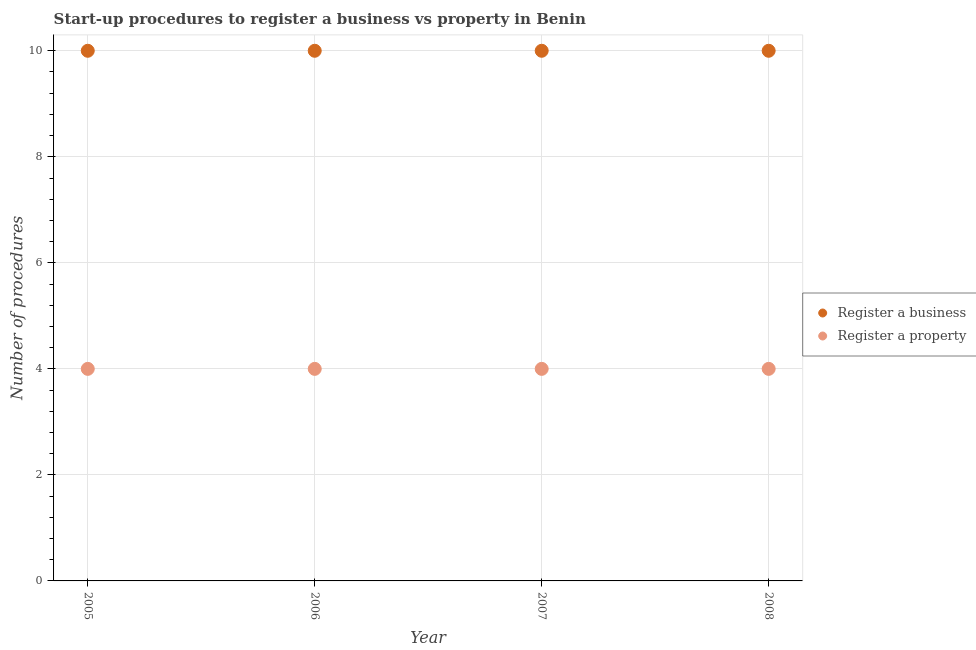Is the number of dotlines equal to the number of legend labels?
Offer a terse response. Yes. What is the number of procedures to register a property in 2005?
Give a very brief answer. 4. Across all years, what is the maximum number of procedures to register a property?
Your response must be concise. 4. Across all years, what is the minimum number of procedures to register a business?
Make the answer very short. 10. In which year was the number of procedures to register a business maximum?
Offer a very short reply. 2005. What is the total number of procedures to register a business in the graph?
Keep it short and to the point. 40. What is the difference between the number of procedures to register a property in 2005 and the number of procedures to register a business in 2008?
Your response must be concise. -6. What is the average number of procedures to register a business per year?
Make the answer very short. 10. In the year 2006, what is the difference between the number of procedures to register a property and number of procedures to register a business?
Make the answer very short. -6. In how many years, is the number of procedures to register a business greater than 2.4?
Ensure brevity in your answer.  4. Is the number of procedures to register a business in 2007 less than that in 2008?
Offer a very short reply. No. Does the number of procedures to register a business monotonically increase over the years?
Offer a terse response. No. Is the number of procedures to register a business strictly greater than the number of procedures to register a property over the years?
Give a very brief answer. Yes. Does the graph contain any zero values?
Provide a succinct answer. No. Does the graph contain grids?
Keep it short and to the point. Yes. How many legend labels are there?
Keep it short and to the point. 2. How are the legend labels stacked?
Provide a short and direct response. Vertical. What is the title of the graph?
Provide a succinct answer. Start-up procedures to register a business vs property in Benin. Does "Resident workers" appear as one of the legend labels in the graph?
Provide a succinct answer. No. What is the label or title of the Y-axis?
Make the answer very short. Number of procedures. What is the Number of procedures in Register a business in 2005?
Give a very brief answer. 10. What is the Number of procedures of Register a property in 2005?
Provide a short and direct response. 4. What is the Number of procedures in Register a property in 2006?
Offer a very short reply. 4. What is the Number of procedures of Register a business in 2007?
Your answer should be compact. 10. What is the Number of procedures in Register a property in 2007?
Offer a very short reply. 4. What is the Number of procedures in Register a property in 2008?
Your answer should be very brief. 4. Across all years, what is the minimum Number of procedures of Register a property?
Make the answer very short. 4. What is the total Number of procedures of Register a business in the graph?
Keep it short and to the point. 40. What is the difference between the Number of procedures in Register a business in 2005 and that in 2006?
Keep it short and to the point. 0. What is the difference between the Number of procedures in Register a property in 2005 and that in 2007?
Give a very brief answer. 0. What is the difference between the Number of procedures in Register a business in 2005 and that in 2008?
Offer a very short reply. 0. What is the difference between the Number of procedures in Register a business in 2006 and that in 2007?
Your response must be concise. 0. What is the difference between the Number of procedures in Register a business in 2006 and that in 2008?
Make the answer very short. 0. What is the difference between the Number of procedures of Register a property in 2006 and that in 2008?
Make the answer very short. 0. What is the difference between the Number of procedures of Register a business in 2005 and the Number of procedures of Register a property in 2006?
Provide a short and direct response. 6. What is the difference between the Number of procedures of Register a business in 2005 and the Number of procedures of Register a property in 2007?
Offer a very short reply. 6. What is the average Number of procedures of Register a business per year?
Provide a succinct answer. 10. What is the average Number of procedures in Register a property per year?
Ensure brevity in your answer.  4. What is the ratio of the Number of procedures of Register a business in 2005 to that in 2006?
Your answer should be very brief. 1. What is the ratio of the Number of procedures in Register a business in 2005 to that in 2007?
Provide a short and direct response. 1. What is the ratio of the Number of procedures of Register a business in 2006 to that in 2007?
Keep it short and to the point. 1. What is the ratio of the Number of procedures of Register a business in 2006 to that in 2008?
Provide a succinct answer. 1. What is the ratio of the Number of procedures of Register a property in 2006 to that in 2008?
Offer a very short reply. 1. What is the ratio of the Number of procedures of Register a business in 2007 to that in 2008?
Provide a succinct answer. 1. What is the ratio of the Number of procedures in Register a property in 2007 to that in 2008?
Make the answer very short. 1. What is the difference between the highest and the second highest Number of procedures of Register a business?
Offer a terse response. 0. What is the difference between the highest and the lowest Number of procedures of Register a property?
Provide a succinct answer. 0. 